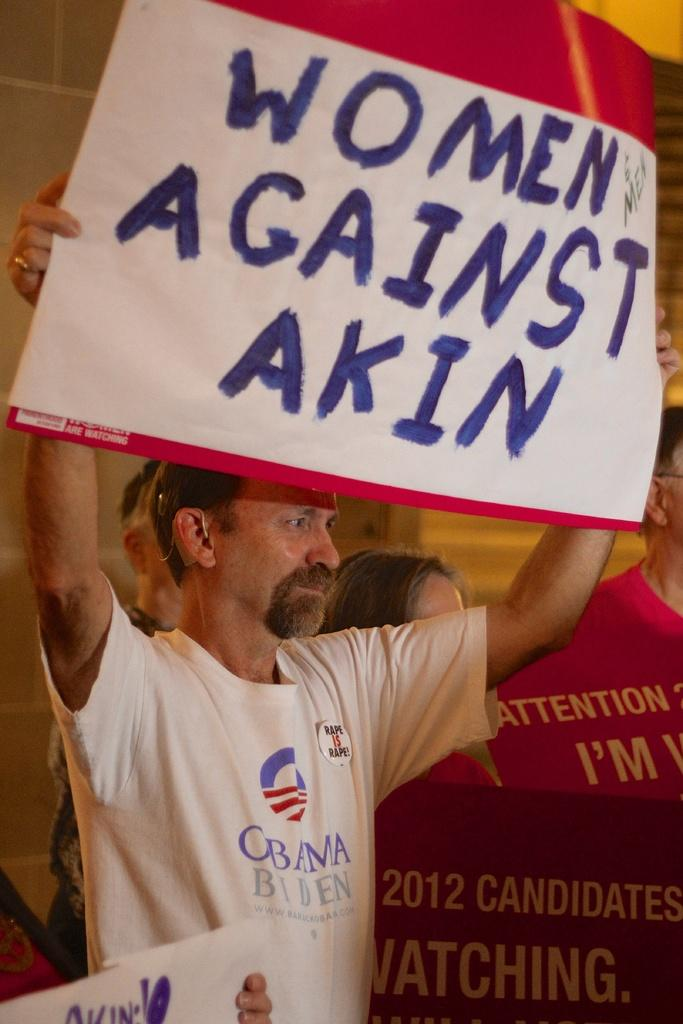<image>
Relay a brief, clear account of the picture shown. A man holds a sign that reads, "Women Against Akin." 